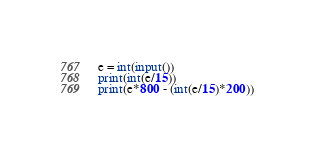<code> <loc_0><loc_0><loc_500><loc_500><_Python_>e = int(input())
print(int(e/15))
print(e*800 - (int(e/15)*200))</code> 